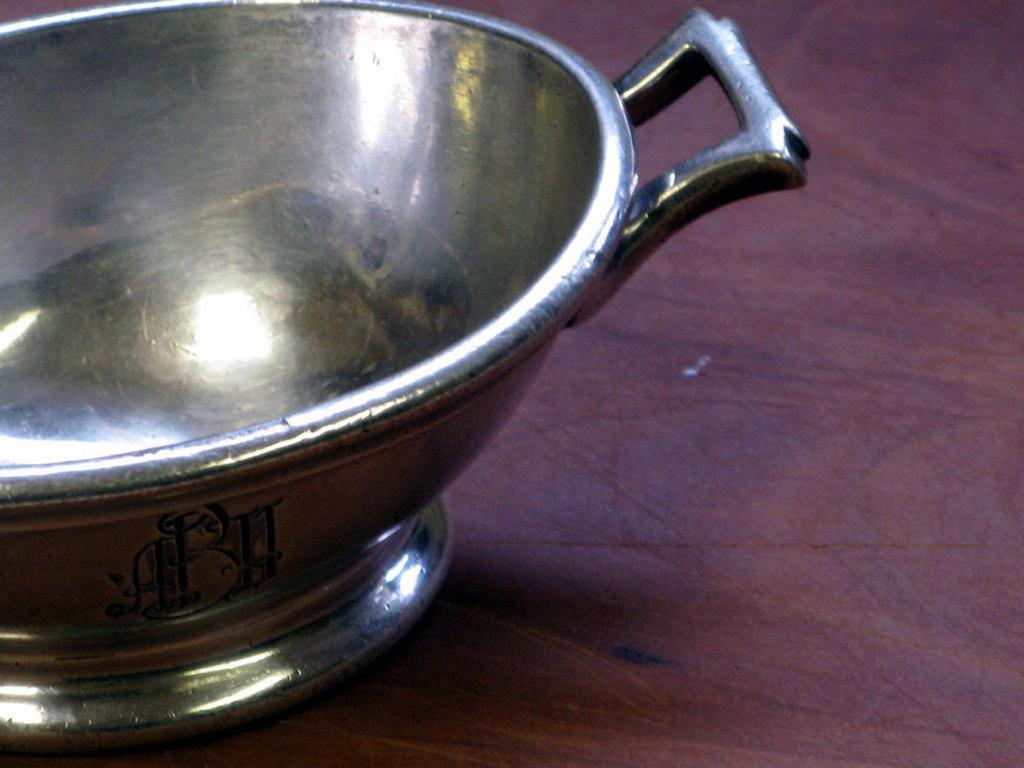In one or two sentences, can you explain what this image depicts? In this image I can see a metal bowl which is silver in color on a pink colored surface. I can see few letters written on the bowl with black color. 